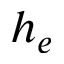<formula> <loc_0><loc_0><loc_500><loc_500>h _ { e }</formula> 